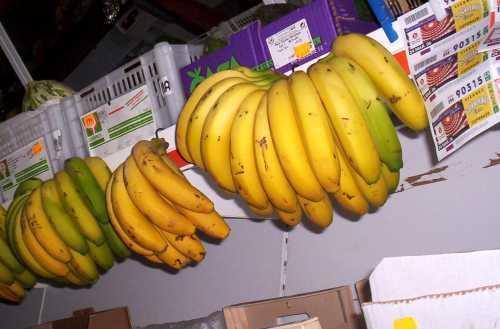How many bundles of bananas are there?
Give a very brief answer. 4. How many bunches of bananas have no green bananas?
Give a very brief answer. 1. 